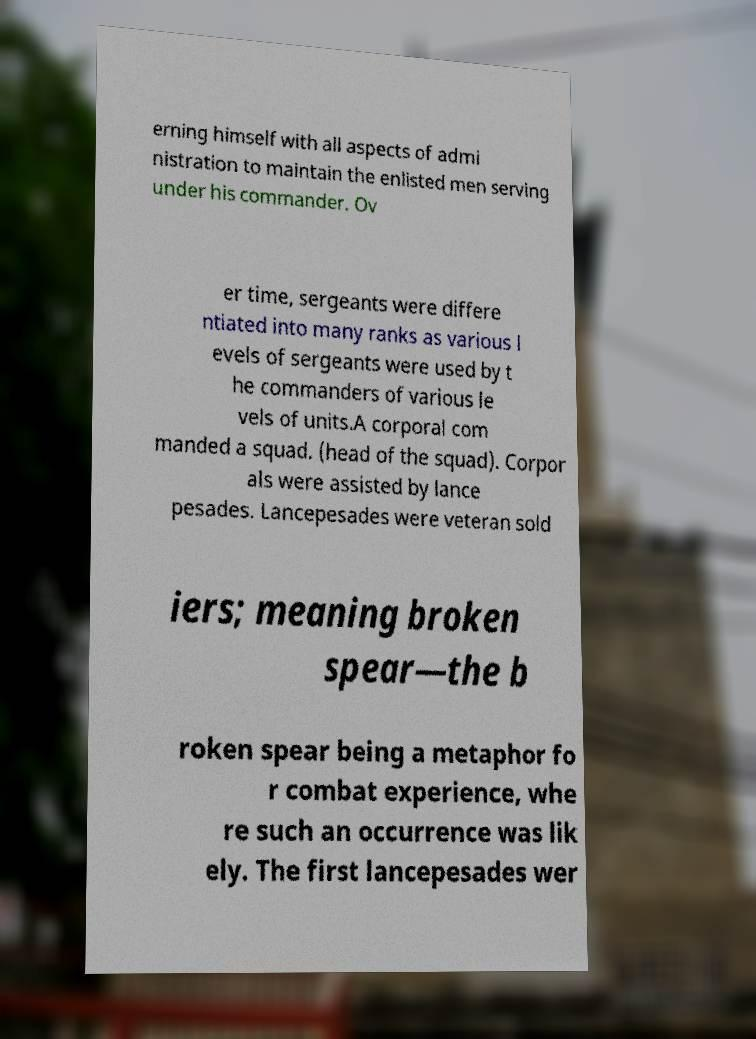Please identify and transcribe the text found in this image. erning himself with all aspects of admi nistration to maintain the enlisted men serving under his commander. Ov er time, sergeants were differe ntiated into many ranks as various l evels of sergeants were used by t he commanders of various le vels of units.A corporal com manded a squad. (head of the squad). Corpor als were assisted by lance pesades. Lancepesades were veteran sold iers; meaning broken spear—the b roken spear being a metaphor fo r combat experience, whe re such an occurrence was lik ely. The first lancepesades wer 